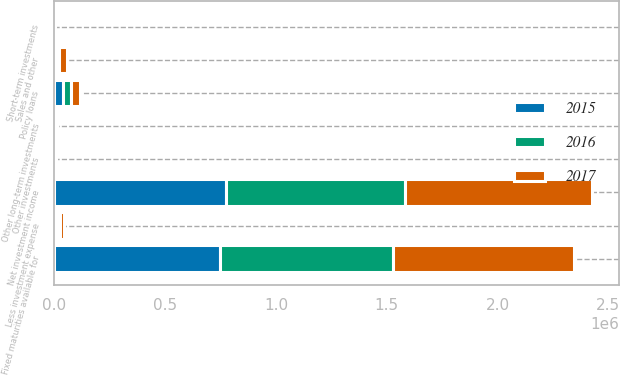Convert chart to OTSL. <chart><loc_0><loc_0><loc_500><loc_500><stacked_bar_chart><ecel><fcel>Fixed maturities available for<fcel>Policy loans<fcel>Other long-term investments<fcel>Short-term investments<fcel>Less investment expense<fcel>Net investment income<fcel>Sales and other<fcel>Other investments<nl><fcel>2017<fcel>817213<fcel>39578<fcel>4991<fcel>948<fcel>14845<fcel>847885<fcel>35199<fcel>7302<nl><fcel>2016<fcel>778912<fcel>38436<fcel>2786<fcel>447<fcel>13678<fcel>806903<fcel>10645<fcel>38<nl><fcel>2015<fcel>747663<fcel>36763<fcel>2021<fcel>95<fcel>12591<fcel>773951<fcel>9479<fcel>688<nl></chart> 